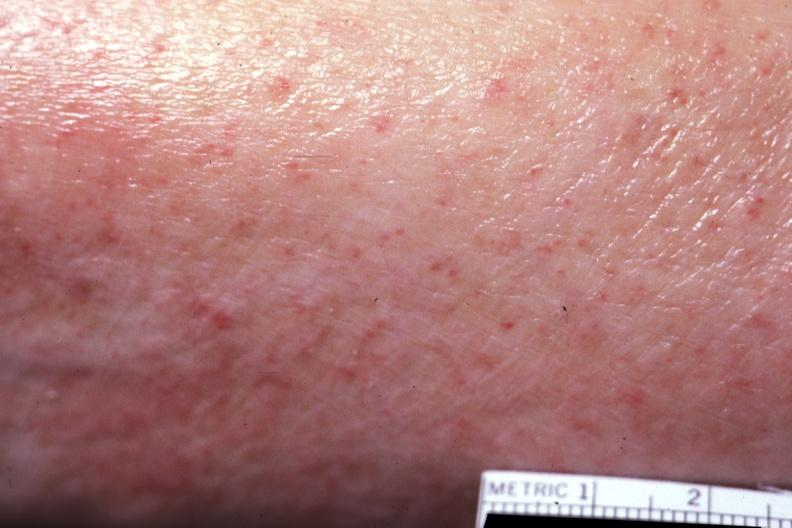does the superior vena cava show close-up well shown?
Answer the question using a single word or phrase. No 